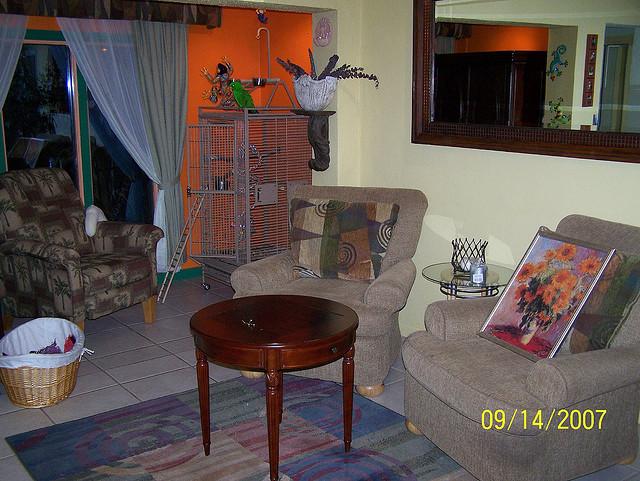What shape is the table?
Give a very brief answer. Circle. When was this picture taken?
Answer briefly. 9/14/2007. What is the date on the picture?
Quick response, please. 09/14/2007. What is embroidered on the chair cushion?
Answer briefly. Nothing. What is in the mirror?
Give a very brief answer. Wall. Is there a painting of van Gogh on one of the chairs?
Short answer required. Yes. 